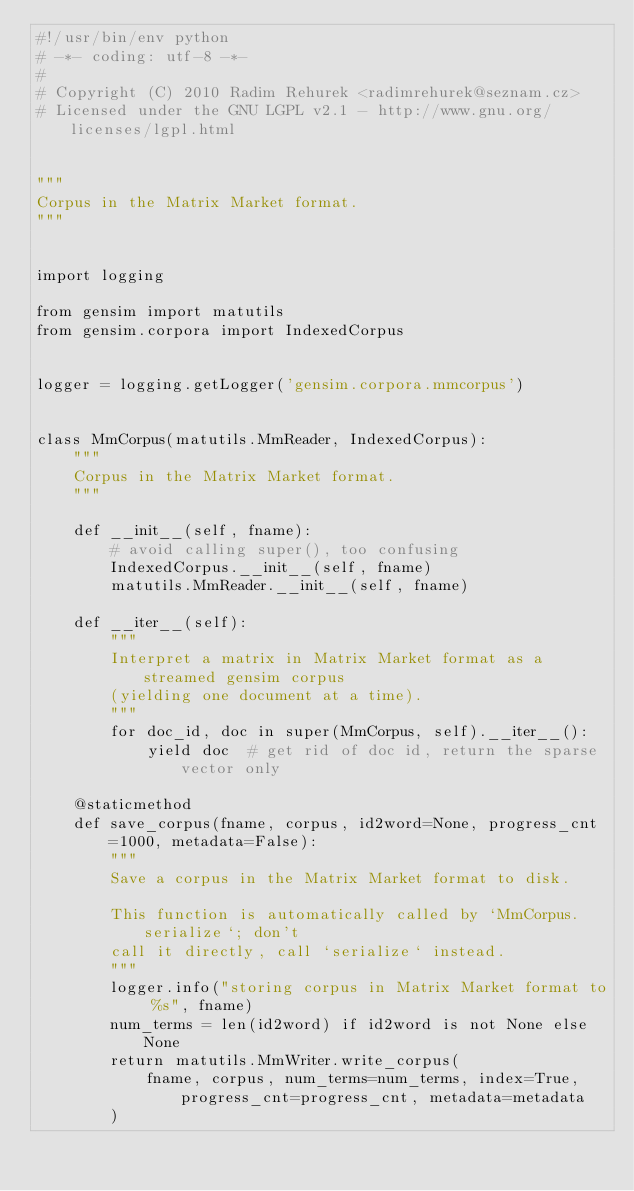Convert code to text. <code><loc_0><loc_0><loc_500><loc_500><_Python_>#!/usr/bin/env python
# -*- coding: utf-8 -*-
#
# Copyright (C) 2010 Radim Rehurek <radimrehurek@seznam.cz>
# Licensed under the GNU LGPL v2.1 - http://www.gnu.org/licenses/lgpl.html


"""
Corpus in the Matrix Market format.
"""


import logging

from gensim import matutils
from gensim.corpora import IndexedCorpus


logger = logging.getLogger('gensim.corpora.mmcorpus')


class MmCorpus(matutils.MmReader, IndexedCorpus):
    """
    Corpus in the Matrix Market format.
    """

    def __init__(self, fname):
        # avoid calling super(), too confusing
        IndexedCorpus.__init__(self, fname)
        matutils.MmReader.__init__(self, fname)

    def __iter__(self):
        """
        Interpret a matrix in Matrix Market format as a streamed gensim corpus
        (yielding one document at a time).
        """
        for doc_id, doc in super(MmCorpus, self).__iter__():
            yield doc  # get rid of doc id, return the sparse vector only

    @staticmethod
    def save_corpus(fname, corpus, id2word=None, progress_cnt=1000, metadata=False):
        """
        Save a corpus in the Matrix Market format to disk.

        This function is automatically called by `MmCorpus.serialize`; don't
        call it directly, call `serialize` instead.
        """
        logger.info("storing corpus in Matrix Market format to %s", fname)
        num_terms = len(id2word) if id2word is not None else None
        return matutils.MmWriter.write_corpus(
            fname, corpus, num_terms=num_terms, index=True, progress_cnt=progress_cnt, metadata=metadata
        )
</code> 